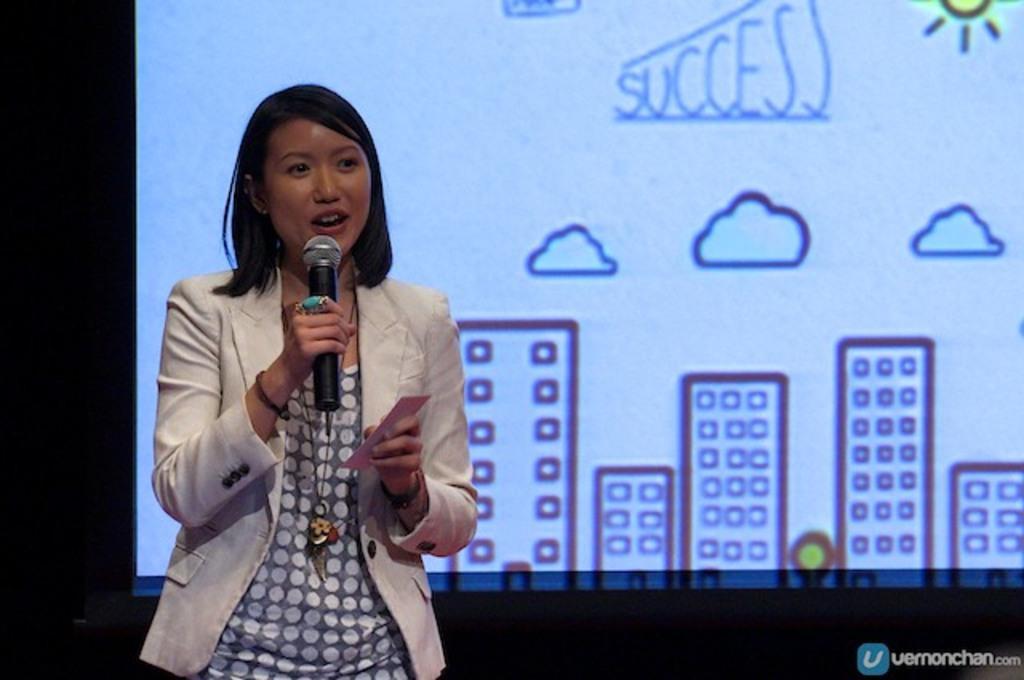Describe this image in one or two sentences. This image is clicked in a meeting. There is a woman standing and talking. She is wearing a white color jacket. And holding a mic in her hand. In the background there is a screen. On which building drawings are projected. 